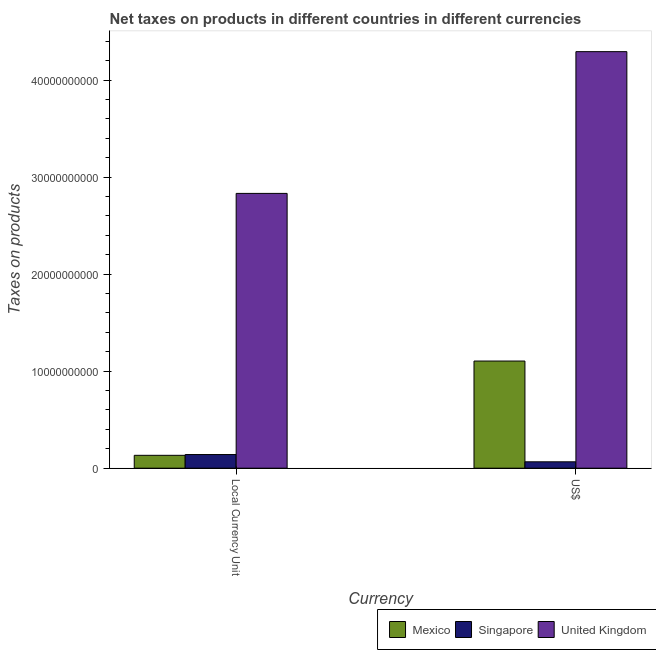How many different coloured bars are there?
Provide a short and direct response. 3. How many groups of bars are there?
Your response must be concise. 2. Are the number of bars per tick equal to the number of legend labels?
Give a very brief answer. Yes. What is the label of the 2nd group of bars from the left?
Provide a short and direct response. US$. What is the net taxes in constant 2005 us$ in United Kingdom?
Ensure brevity in your answer.  2.83e+1. Across all countries, what is the maximum net taxes in constant 2005 us$?
Keep it short and to the point. 2.83e+1. Across all countries, what is the minimum net taxes in constant 2005 us$?
Offer a terse response. 1.33e+09. In which country was the net taxes in us$ maximum?
Your response must be concise. United Kingdom. What is the total net taxes in constant 2005 us$ in the graph?
Provide a short and direct response. 3.10e+1. What is the difference between the net taxes in us$ in Mexico and that in United Kingdom?
Your answer should be very brief. -3.19e+1. What is the difference between the net taxes in us$ in Mexico and the net taxes in constant 2005 us$ in Singapore?
Offer a terse response. 9.63e+09. What is the average net taxes in constant 2005 us$ per country?
Ensure brevity in your answer.  1.03e+1. What is the difference between the net taxes in us$ and net taxes in constant 2005 us$ in Mexico?
Offer a terse response. 9.71e+09. What is the ratio of the net taxes in constant 2005 us$ in United Kingdom to that in Singapore?
Keep it short and to the point. 20.12. Is the net taxes in constant 2005 us$ in Mexico less than that in United Kingdom?
Offer a very short reply. Yes. What does the 1st bar from the left in Local Currency Unit represents?
Provide a succinct answer. Mexico. What does the 2nd bar from the right in US$ represents?
Offer a very short reply. Singapore. How many countries are there in the graph?
Offer a terse response. 3. Does the graph contain any zero values?
Offer a very short reply. No. How many legend labels are there?
Provide a short and direct response. 3. How are the legend labels stacked?
Give a very brief answer. Horizontal. What is the title of the graph?
Keep it short and to the point. Net taxes on products in different countries in different currencies. Does "El Salvador" appear as one of the legend labels in the graph?
Offer a very short reply. No. What is the label or title of the X-axis?
Give a very brief answer. Currency. What is the label or title of the Y-axis?
Provide a succinct answer. Taxes on products. What is the Taxes on products in Mexico in Local Currency Unit?
Your response must be concise. 1.33e+09. What is the Taxes on products of Singapore in Local Currency Unit?
Offer a terse response. 1.41e+09. What is the Taxes on products of United Kingdom in Local Currency Unit?
Offer a terse response. 2.83e+1. What is the Taxes on products of Mexico in US$?
Provide a succinct answer. 1.10e+1. What is the Taxes on products in Singapore in US$?
Offer a very short reply. 6.57e+08. What is the Taxes on products of United Kingdom in US$?
Make the answer very short. 4.29e+1. Across all Currency, what is the maximum Taxes on products of Mexico?
Offer a very short reply. 1.10e+1. Across all Currency, what is the maximum Taxes on products in Singapore?
Offer a terse response. 1.41e+09. Across all Currency, what is the maximum Taxes on products in United Kingdom?
Provide a succinct answer. 4.29e+1. Across all Currency, what is the minimum Taxes on products in Mexico?
Your response must be concise. 1.33e+09. Across all Currency, what is the minimum Taxes on products in Singapore?
Offer a very short reply. 6.57e+08. Across all Currency, what is the minimum Taxes on products in United Kingdom?
Offer a very short reply. 2.83e+1. What is the total Taxes on products of Mexico in the graph?
Provide a succinct answer. 1.24e+1. What is the total Taxes on products in Singapore in the graph?
Your response must be concise. 2.06e+09. What is the total Taxes on products in United Kingdom in the graph?
Offer a terse response. 7.12e+1. What is the difference between the Taxes on products in Mexico in Local Currency Unit and that in US$?
Keep it short and to the point. -9.71e+09. What is the difference between the Taxes on products of Singapore in Local Currency Unit and that in US$?
Make the answer very short. 7.50e+08. What is the difference between the Taxes on products of United Kingdom in Local Currency Unit and that in US$?
Make the answer very short. -1.46e+1. What is the difference between the Taxes on products in Mexico in Local Currency Unit and the Taxes on products in Singapore in US$?
Provide a succinct answer. 6.69e+08. What is the difference between the Taxes on products of Mexico in Local Currency Unit and the Taxes on products of United Kingdom in US$?
Give a very brief answer. -4.16e+1. What is the difference between the Taxes on products of Singapore in Local Currency Unit and the Taxes on products of United Kingdom in US$?
Give a very brief answer. -4.15e+1. What is the average Taxes on products of Mexico per Currency?
Ensure brevity in your answer.  6.18e+09. What is the average Taxes on products of Singapore per Currency?
Make the answer very short. 1.03e+09. What is the average Taxes on products of United Kingdom per Currency?
Your answer should be very brief. 3.56e+1. What is the difference between the Taxes on products in Mexico and Taxes on products in Singapore in Local Currency Unit?
Ensure brevity in your answer.  -8.10e+07. What is the difference between the Taxes on products of Mexico and Taxes on products of United Kingdom in Local Currency Unit?
Your response must be concise. -2.70e+1. What is the difference between the Taxes on products of Singapore and Taxes on products of United Kingdom in Local Currency Unit?
Your response must be concise. -2.69e+1. What is the difference between the Taxes on products in Mexico and Taxes on products in Singapore in US$?
Your response must be concise. 1.04e+1. What is the difference between the Taxes on products of Mexico and Taxes on products of United Kingdom in US$?
Your answer should be compact. -3.19e+1. What is the difference between the Taxes on products in Singapore and Taxes on products in United Kingdom in US$?
Your answer should be very brief. -4.23e+1. What is the ratio of the Taxes on products of Mexico in Local Currency Unit to that in US$?
Offer a very short reply. 0.12. What is the ratio of the Taxes on products of Singapore in Local Currency Unit to that in US$?
Your response must be concise. 2.14. What is the ratio of the Taxes on products of United Kingdom in Local Currency Unit to that in US$?
Offer a very short reply. 0.66. What is the difference between the highest and the second highest Taxes on products of Mexico?
Your answer should be very brief. 9.71e+09. What is the difference between the highest and the second highest Taxes on products in Singapore?
Provide a short and direct response. 7.50e+08. What is the difference between the highest and the second highest Taxes on products of United Kingdom?
Give a very brief answer. 1.46e+1. What is the difference between the highest and the lowest Taxes on products in Mexico?
Provide a short and direct response. 9.71e+09. What is the difference between the highest and the lowest Taxes on products of Singapore?
Provide a succinct answer. 7.50e+08. What is the difference between the highest and the lowest Taxes on products of United Kingdom?
Your answer should be compact. 1.46e+1. 